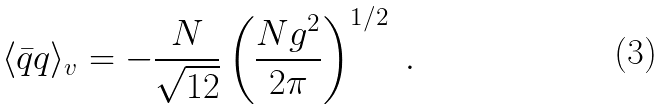Convert formula to latex. <formula><loc_0><loc_0><loc_500><loc_500>\langle \bar { q } q \rangle _ { v } = - \frac { N } { \sqrt { 1 2 } } \left ( \frac { N g ^ { 2 } } { 2 \pi } \right ) ^ { 1 / 2 } \ .</formula> 